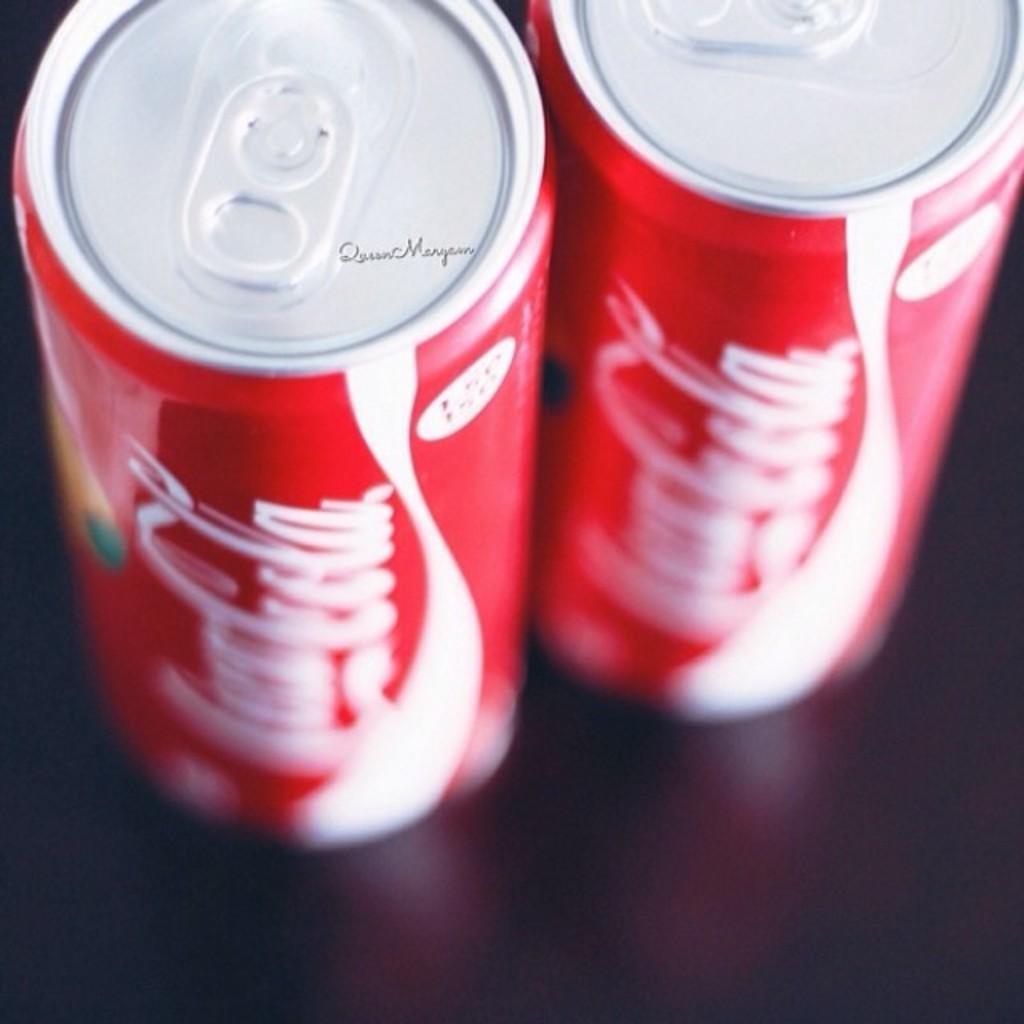What kind of soda is it?
Provide a succinct answer. Coca cola. 